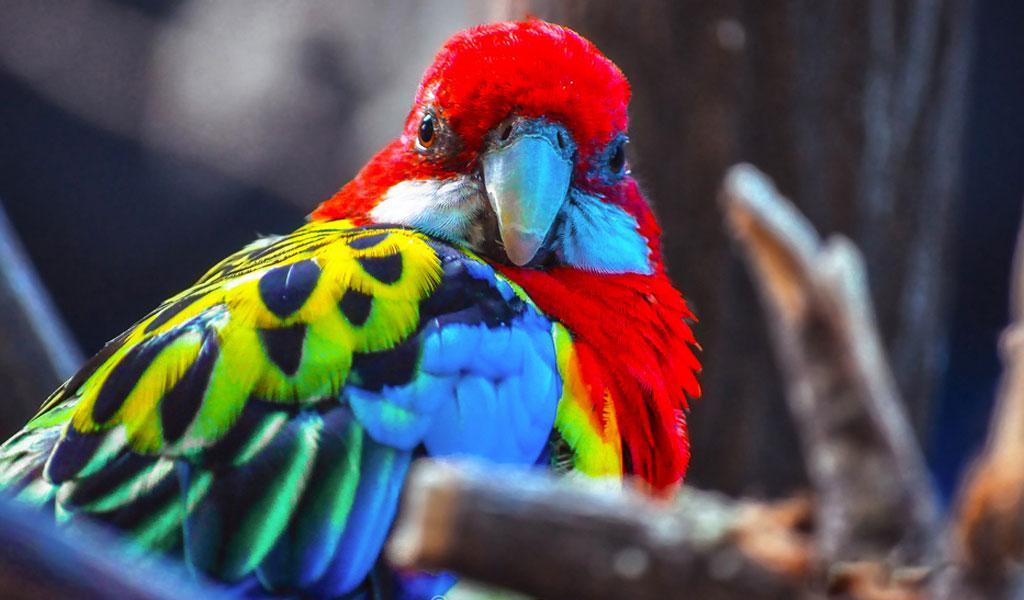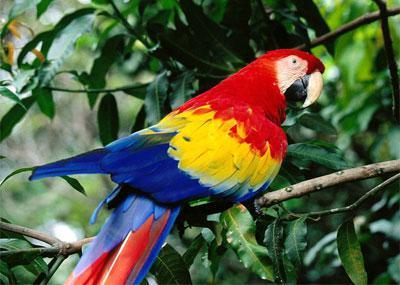The first image is the image on the left, the second image is the image on the right. Assess this claim about the two images: "At least one image shows a red-headed parrot lifting a kind of nut with one claw towards its beak.". Correct or not? Answer yes or no. No. The first image is the image on the left, the second image is the image on the right. Considering the images on both sides, is "A parrot is eating something in at least one of the images." valid? Answer yes or no. No. 